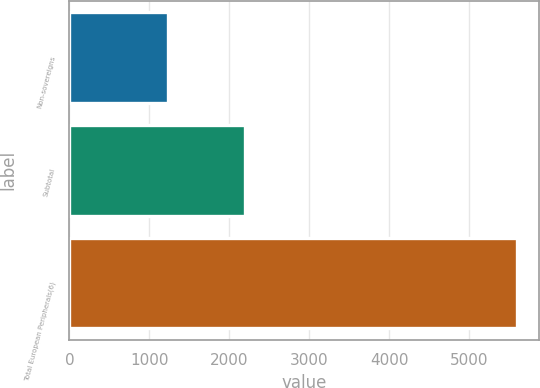Convert chart to OTSL. <chart><loc_0><loc_0><loc_500><loc_500><bar_chart><fcel>Non-sovereigns<fcel>Subtotal<fcel>Total European Peripherals(6)<nl><fcel>1239<fcel>2193<fcel>5602<nl></chart> 